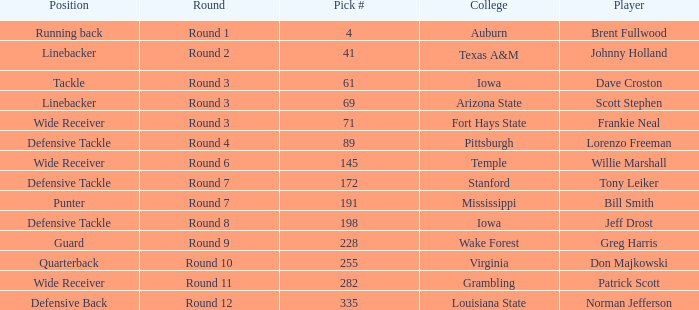Which college had Tony Leiker in round 7? Stanford. 